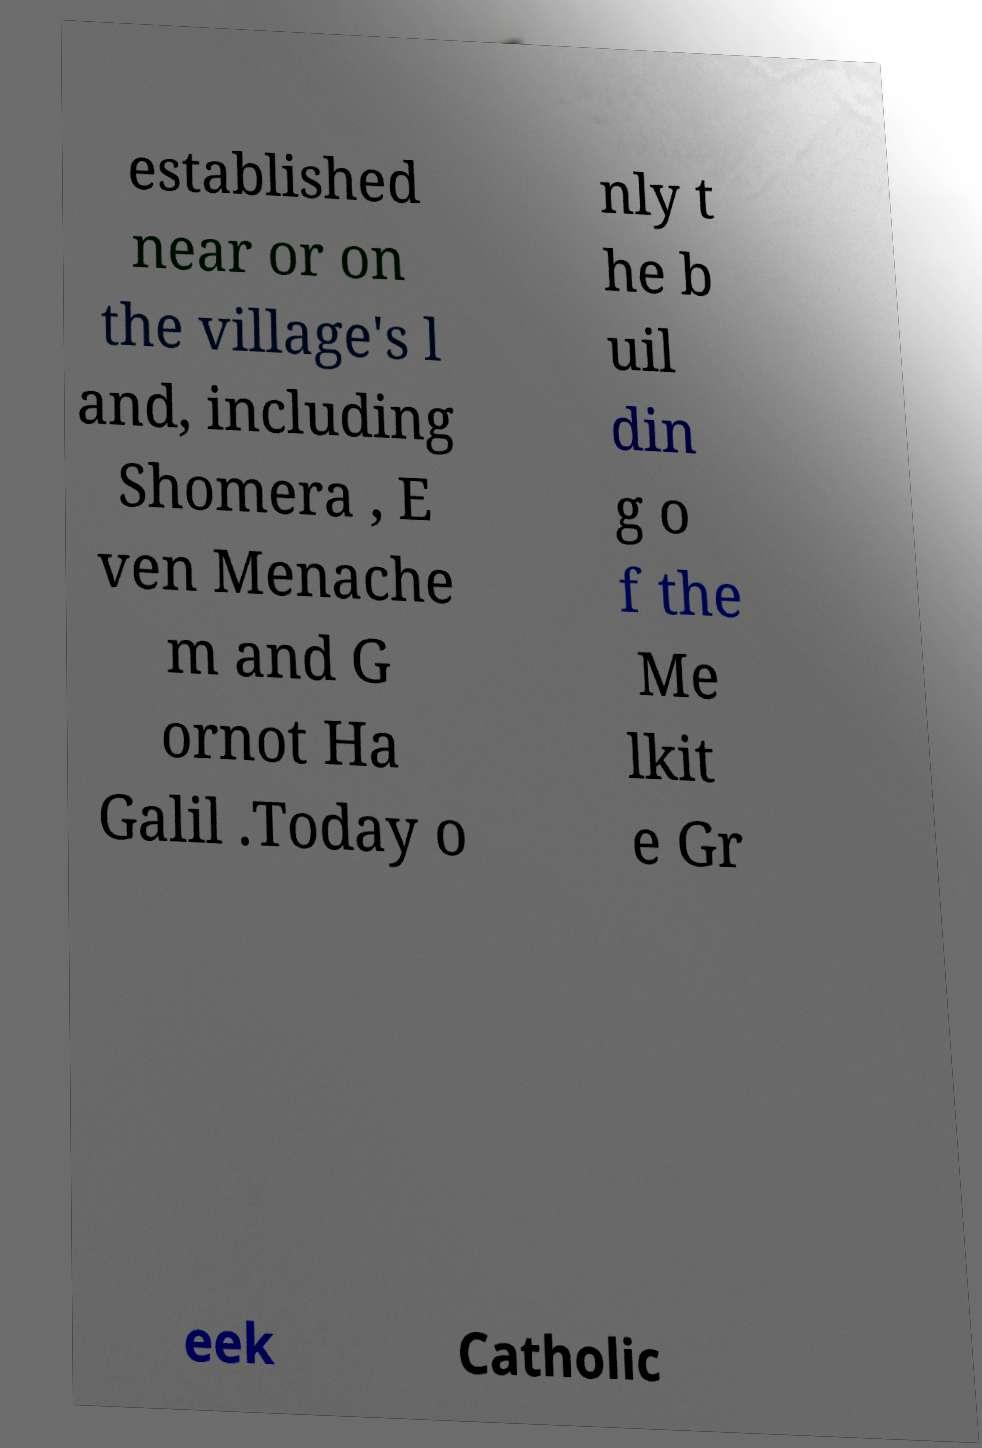Please identify and transcribe the text found in this image. established near or on the village's l and, including Shomera , E ven Menache m and G ornot Ha Galil .Today o nly t he b uil din g o f the Me lkit e Gr eek Catholic 